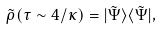Convert formula to latex. <formula><loc_0><loc_0><loc_500><loc_500>\tilde { \rho } ( \tau \sim 4 / \kappa ) = | \tilde { \Psi } \rangle \langle \tilde { \Psi } | ,</formula> 